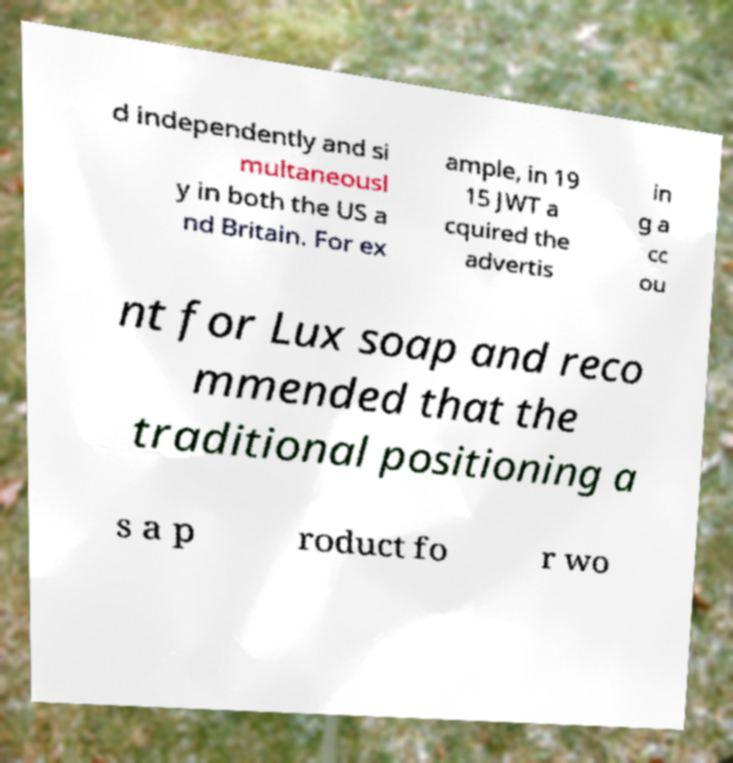Could you extract and type out the text from this image? d independently and si multaneousl y in both the US a nd Britain. For ex ample, in 19 15 JWT a cquired the advertis in g a cc ou nt for Lux soap and reco mmended that the traditional positioning a s a p roduct fo r wo 